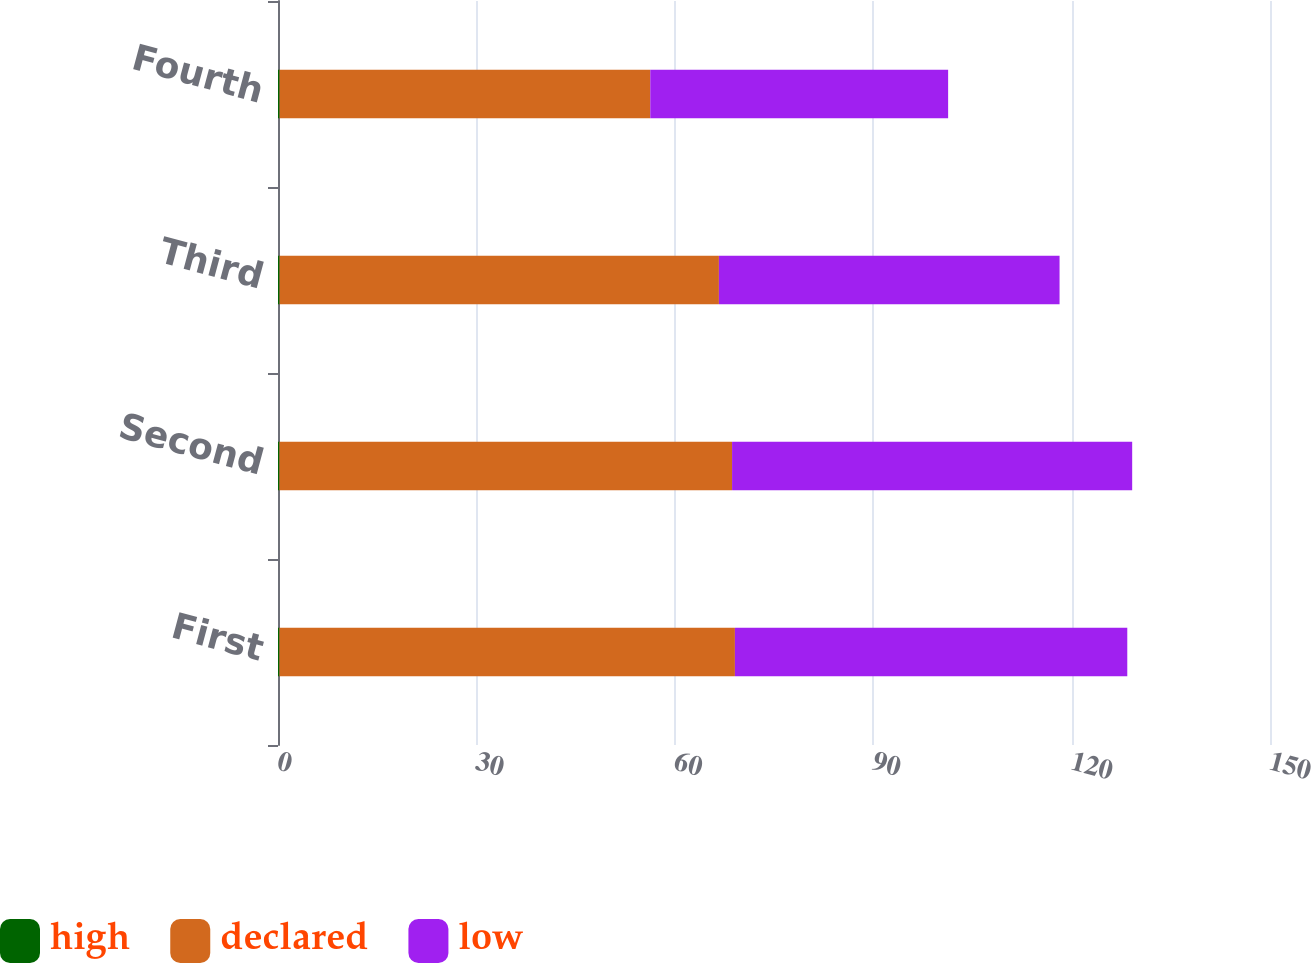<chart> <loc_0><loc_0><loc_500><loc_500><stacked_bar_chart><ecel><fcel>First<fcel>Second<fcel>Third<fcel>Fourth<nl><fcel>high<fcel>0.22<fcel>0.22<fcel>0.24<fcel>0.24<nl><fcel>declared<fcel>68.87<fcel>68.44<fcel>66.43<fcel>56.05<nl><fcel>low<fcel>59.33<fcel>60.5<fcel>51.51<fcel>45.04<nl></chart> 